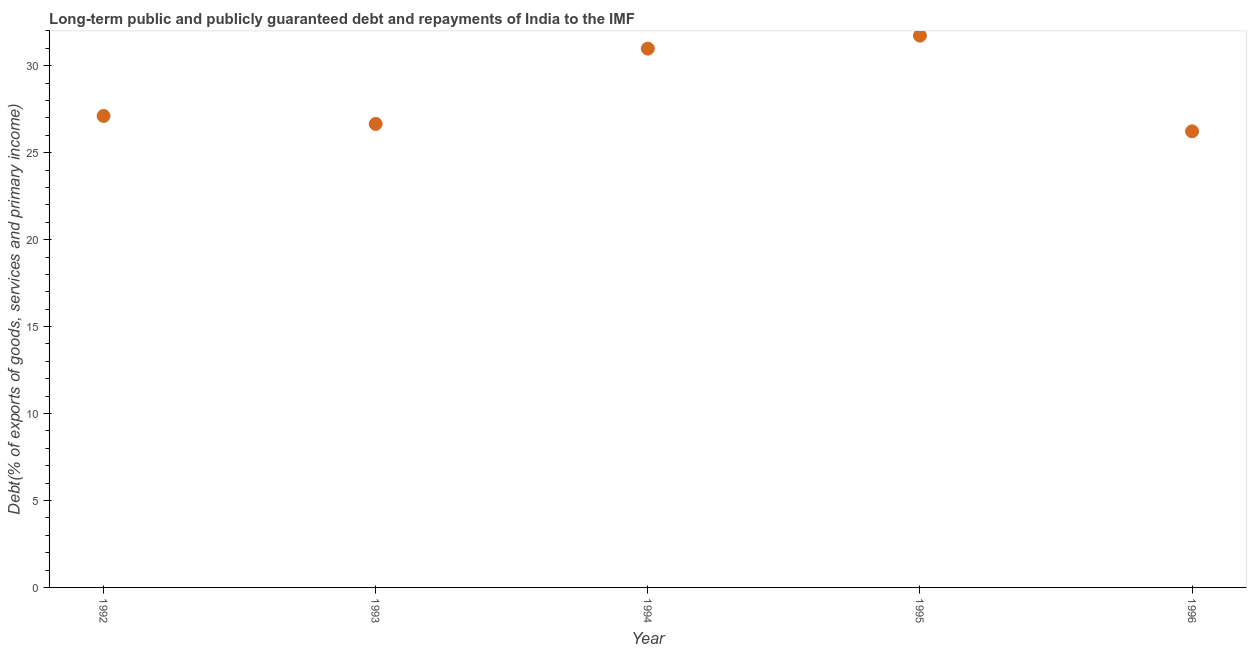What is the debt service in 1995?
Provide a short and direct response. 31.73. Across all years, what is the maximum debt service?
Provide a succinct answer. 31.73. Across all years, what is the minimum debt service?
Make the answer very short. 26.23. In which year was the debt service minimum?
Provide a short and direct response. 1996. What is the sum of the debt service?
Offer a terse response. 142.72. What is the difference between the debt service in 1992 and 1994?
Keep it short and to the point. -3.87. What is the average debt service per year?
Your answer should be compact. 28.54. What is the median debt service?
Your answer should be very brief. 27.11. In how many years, is the debt service greater than 11 %?
Your answer should be compact. 5. Do a majority of the years between 1992 and 1995 (inclusive) have debt service greater than 19 %?
Offer a terse response. Yes. What is the ratio of the debt service in 1995 to that in 1996?
Provide a short and direct response. 1.21. Is the debt service in 1993 less than that in 1995?
Your answer should be very brief. Yes. What is the difference between the highest and the second highest debt service?
Your answer should be very brief. 0.75. Is the sum of the debt service in 1993 and 1994 greater than the maximum debt service across all years?
Ensure brevity in your answer.  Yes. What is the difference between the highest and the lowest debt service?
Offer a very short reply. 5.5. In how many years, is the debt service greater than the average debt service taken over all years?
Ensure brevity in your answer.  2. Does the debt service monotonically increase over the years?
Make the answer very short. No. How many years are there in the graph?
Offer a terse response. 5. Does the graph contain any zero values?
Offer a terse response. No. Does the graph contain grids?
Offer a terse response. No. What is the title of the graph?
Your response must be concise. Long-term public and publicly guaranteed debt and repayments of India to the IMF. What is the label or title of the Y-axis?
Keep it short and to the point. Debt(% of exports of goods, services and primary income). What is the Debt(% of exports of goods, services and primary income) in 1992?
Ensure brevity in your answer.  27.11. What is the Debt(% of exports of goods, services and primary income) in 1993?
Your response must be concise. 26.66. What is the Debt(% of exports of goods, services and primary income) in 1994?
Your response must be concise. 30.99. What is the Debt(% of exports of goods, services and primary income) in 1995?
Give a very brief answer. 31.73. What is the Debt(% of exports of goods, services and primary income) in 1996?
Offer a very short reply. 26.23. What is the difference between the Debt(% of exports of goods, services and primary income) in 1992 and 1993?
Provide a short and direct response. 0.46. What is the difference between the Debt(% of exports of goods, services and primary income) in 1992 and 1994?
Give a very brief answer. -3.87. What is the difference between the Debt(% of exports of goods, services and primary income) in 1992 and 1995?
Provide a succinct answer. -4.62. What is the difference between the Debt(% of exports of goods, services and primary income) in 1992 and 1996?
Your answer should be very brief. 0.89. What is the difference between the Debt(% of exports of goods, services and primary income) in 1993 and 1994?
Your answer should be very brief. -4.33. What is the difference between the Debt(% of exports of goods, services and primary income) in 1993 and 1995?
Offer a very short reply. -5.08. What is the difference between the Debt(% of exports of goods, services and primary income) in 1993 and 1996?
Your answer should be compact. 0.43. What is the difference between the Debt(% of exports of goods, services and primary income) in 1994 and 1995?
Offer a very short reply. -0.75. What is the difference between the Debt(% of exports of goods, services and primary income) in 1994 and 1996?
Offer a terse response. 4.76. What is the difference between the Debt(% of exports of goods, services and primary income) in 1995 and 1996?
Ensure brevity in your answer.  5.5. What is the ratio of the Debt(% of exports of goods, services and primary income) in 1992 to that in 1994?
Your response must be concise. 0.88. What is the ratio of the Debt(% of exports of goods, services and primary income) in 1992 to that in 1995?
Ensure brevity in your answer.  0.85. What is the ratio of the Debt(% of exports of goods, services and primary income) in 1992 to that in 1996?
Give a very brief answer. 1.03. What is the ratio of the Debt(% of exports of goods, services and primary income) in 1993 to that in 1994?
Offer a terse response. 0.86. What is the ratio of the Debt(% of exports of goods, services and primary income) in 1993 to that in 1995?
Ensure brevity in your answer.  0.84. What is the ratio of the Debt(% of exports of goods, services and primary income) in 1993 to that in 1996?
Provide a succinct answer. 1.02. What is the ratio of the Debt(% of exports of goods, services and primary income) in 1994 to that in 1996?
Your answer should be very brief. 1.18. What is the ratio of the Debt(% of exports of goods, services and primary income) in 1995 to that in 1996?
Give a very brief answer. 1.21. 